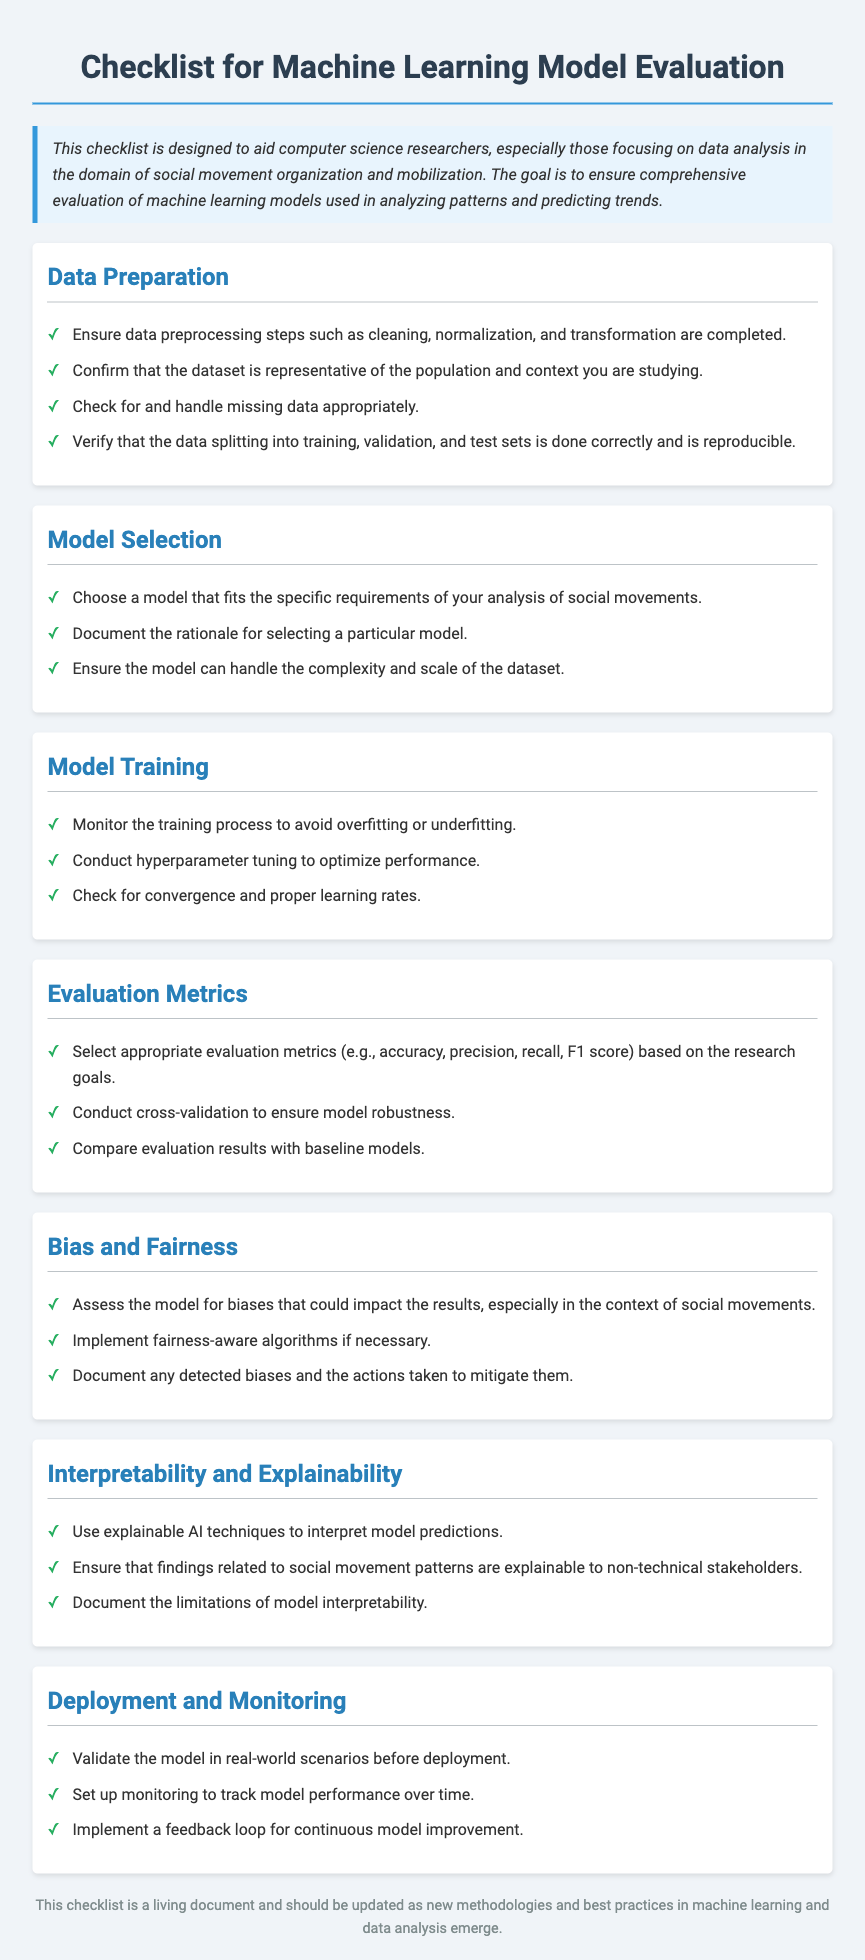What is the title of the checklist? The title is stated prominently at the beginning of the document.
Answer: Checklist for Machine Learning Model Evaluation What section comes after Model Training? The sections are listed in a specific order, making it easy to locate them.
Answer: Evaluation Metrics How many evaluation metrics are recommended in the document? The document specifies a range of evaluation metrics in the corresponding section.
Answer: Four What is one of the specific aspects assessed under Bias and Fairness? This is explicitly mentioned in the Bias and Fairness section of the checklist.
Answer: Model biases Which section addresses the use of explainable AI techniques? This section is clearly labeled and focuses on this subject matter.
Answer: Interpretability and Explainability What action is suggested for model validation before deployment? Validating the model is emphasized as a crucial step in one of the checklist sections.
Answer: Real-world scenarios What is the purpose of the feedback loop mentioned in Deployment and Monitoring? The objective of the feedback loop is explicitly stated in the document.
Answer: Continuous model improvement What should be documented according to Bias and Fairness? This is specified clearly in the checklist as a necessary action.
Answer: Detected biases 